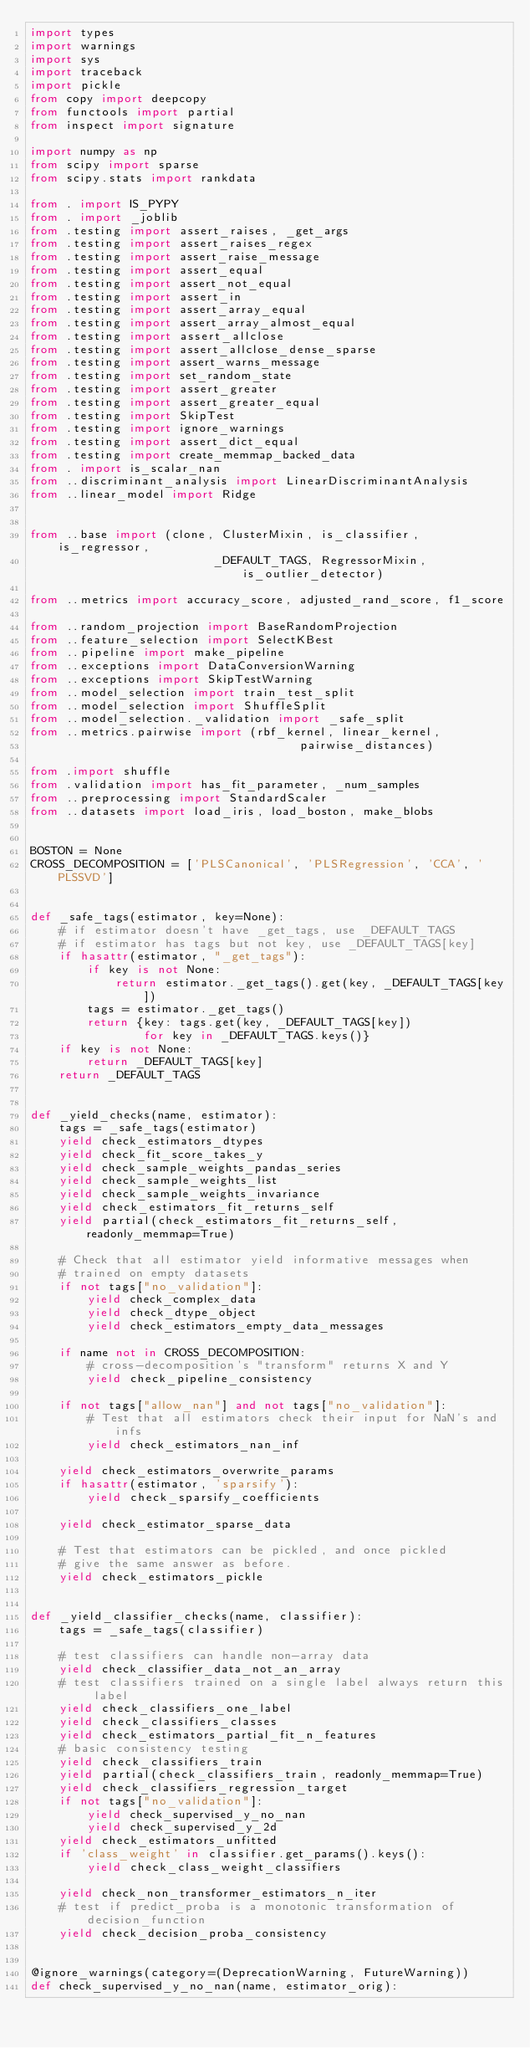Convert code to text. <code><loc_0><loc_0><loc_500><loc_500><_Python_>import types
import warnings
import sys
import traceback
import pickle
from copy import deepcopy
from functools import partial
from inspect import signature

import numpy as np
from scipy import sparse
from scipy.stats import rankdata

from . import IS_PYPY
from . import _joblib
from .testing import assert_raises, _get_args
from .testing import assert_raises_regex
from .testing import assert_raise_message
from .testing import assert_equal
from .testing import assert_not_equal
from .testing import assert_in
from .testing import assert_array_equal
from .testing import assert_array_almost_equal
from .testing import assert_allclose
from .testing import assert_allclose_dense_sparse
from .testing import assert_warns_message
from .testing import set_random_state
from .testing import assert_greater
from .testing import assert_greater_equal
from .testing import SkipTest
from .testing import ignore_warnings
from .testing import assert_dict_equal
from .testing import create_memmap_backed_data
from . import is_scalar_nan
from ..discriminant_analysis import LinearDiscriminantAnalysis
from ..linear_model import Ridge


from ..base import (clone, ClusterMixin, is_classifier, is_regressor,
                          _DEFAULT_TAGS, RegressorMixin, is_outlier_detector)

from ..metrics import accuracy_score, adjusted_rand_score, f1_score

from ..random_projection import BaseRandomProjection
from ..feature_selection import SelectKBest
from ..pipeline import make_pipeline
from ..exceptions import DataConversionWarning
from ..exceptions import SkipTestWarning
from ..model_selection import train_test_split
from ..model_selection import ShuffleSplit
from ..model_selection._validation import _safe_split
from ..metrics.pairwise import (rbf_kernel, linear_kernel,
                                      pairwise_distances)

from .import shuffle
from .validation import has_fit_parameter, _num_samples
from ..preprocessing import StandardScaler
from ..datasets import load_iris, load_boston, make_blobs


BOSTON = None
CROSS_DECOMPOSITION = ['PLSCanonical', 'PLSRegression', 'CCA', 'PLSSVD']


def _safe_tags(estimator, key=None):
    # if estimator doesn't have _get_tags, use _DEFAULT_TAGS
    # if estimator has tags but not key, use _DEFAULT_TAGS[key]
    if hasattr(estimator, "_get_tags"):
        if key is not None:
            return estimator._get_tags().get(key, _DEFAULT_TAGS[key])
        tags = estimator._get_tags()
        return {key: tags.get(key, _DEFAULT_TAGS[key])
                for key in _DEFAULT_TAGS.keys()}
    if key is not None:
        return _DEFAULT_TAGS[key]
    return _DEFAULT_TAGS


def _yield_checks(name, estimator):
    tags = _safe_tags(estimator)
    yield check_estimators_dtypes
    yield check_fit_score_takes_y
    yield check_sample_weights_pandas_series
    yield check_sample_weights_list
    yield check_sample_weights_invariance
    yield check_estimators_fit_returns_self
    yield partial(check_estimators_fit_returns_self, readonly_memmap=True)

    # Check that all estimator yield informative messages when
    # trained on empty datasets
    if not tags["no_validation"]:
        yield check_complex_data
        yield check_dtype_object
        yield check_estimators_empty_data_messages

    if name not in CROSS_DECOMPOSITION:
        # cross-decomposition's "transform" returns X and Y
        yield check_pipeline_consistency

    if not tags["allow_nan"] and not tags["no_validation"]:
        # Test that all estimators check their input for NaN's and infs
        yield check_estimators_nan_inf

    yield check_estimators_overwrite_params
    if hasattr(estimator, 'sparsify'):
        yield check_sparsify_coefficients

    yield check_estimator_sparse_data

    # Test that estimators can be pickled, and once pickled
    # give the same answer as before.
    yield check_estimators_pickle


def _yield_classifier_checks(name, classifier):
    tags = _safe_tags(classifier)

    # test classifiers can handle non-array data
    yield check_classifier_data_not_an_array
    # test classifiers trained on a single label always return this label
    yield check_classifiers_one_label
    yield check_classifiers_classes
    yield check_estimators_partial_fit_n_features
    # basic consistency testing
    yield check_classifiers_train
    yield partial(check_classifiers_train, readonly_memmap=True)
    yield check_classifiers_regression_target
    if not tags["no_validation"]:
        yield check_supervised_y_no_nan
        yield check_supervised_y_2d
    yield check_estimators_unfitted
    if 'class_weight' in classifier.get_params().keys():
        yield check_class_weight_classifiers

    yield check_non_transformer_estimators_n_iter
    # test if predict_proba is a monotonic transformation of decision_function
    yield check_decision_proba_consistency


@ignore_warnings(category=(DeprecationWarning, FutureWarning))
def check_supervised_y_no_nan(name, estimator_orig):</code> 